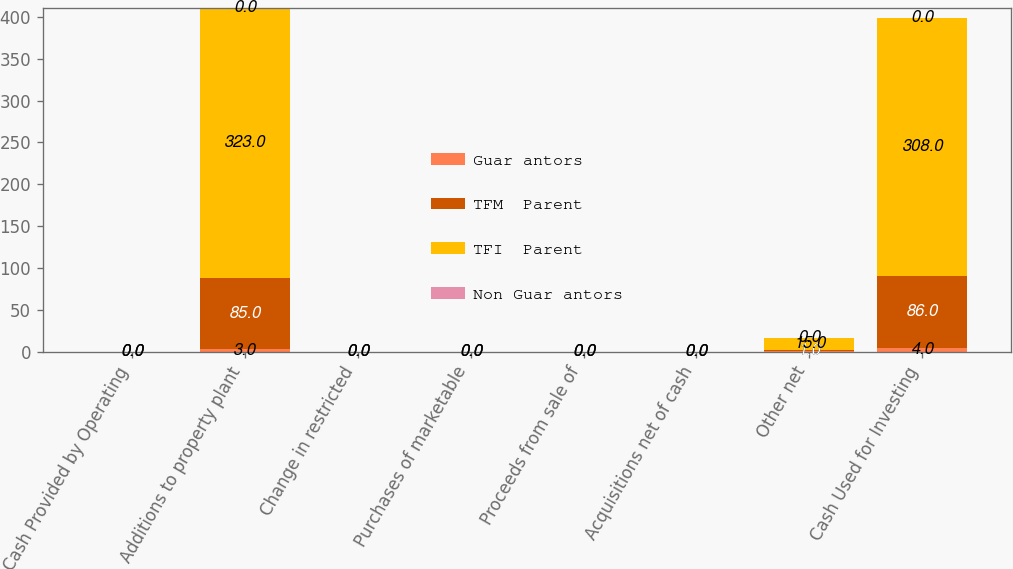Convert chart to OTSL. <chart><loc_0><loc_0><loc_500><loc_500><stacked_bar_chart><ecel><fcel>Cash Provided by Operating<fcel>Additions to property plant<fcel>Change in restricted<fcel>Purchases of marketable<fcel>Proceeds from sale of<fcel>Acquisitions net of cash<fcel>Other net<fcel>Cash Used for Investing<nl><fcel>Guar antors<fcel>0<fcel>3<fcel>0<fcel>0<fcel>0<fcel>0<fcel>1<fcel>4<nl><fcel>TFM  Parent<fcel>0<fcel>85<fcel>0<fcel>0<fcel>0<fcel>0<fcel>1<fcel>86<nl><fcel>TFI  Parent<fcel>0<fcel>323<fcel>0<fcel>0<fcel>0<fcel>0<fcel>15<fcel>308<nl><fcel>Non Guar antors<fcel>0<fcel>0<fcel>0<fcel>0<fcel>0<fcel>0<fcel>0<fcel>0<nl></chart> 